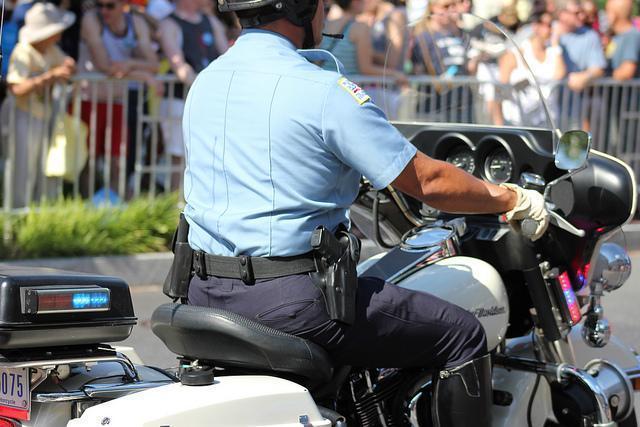How many people are in the photo?
Give a very brief answer. 11. 